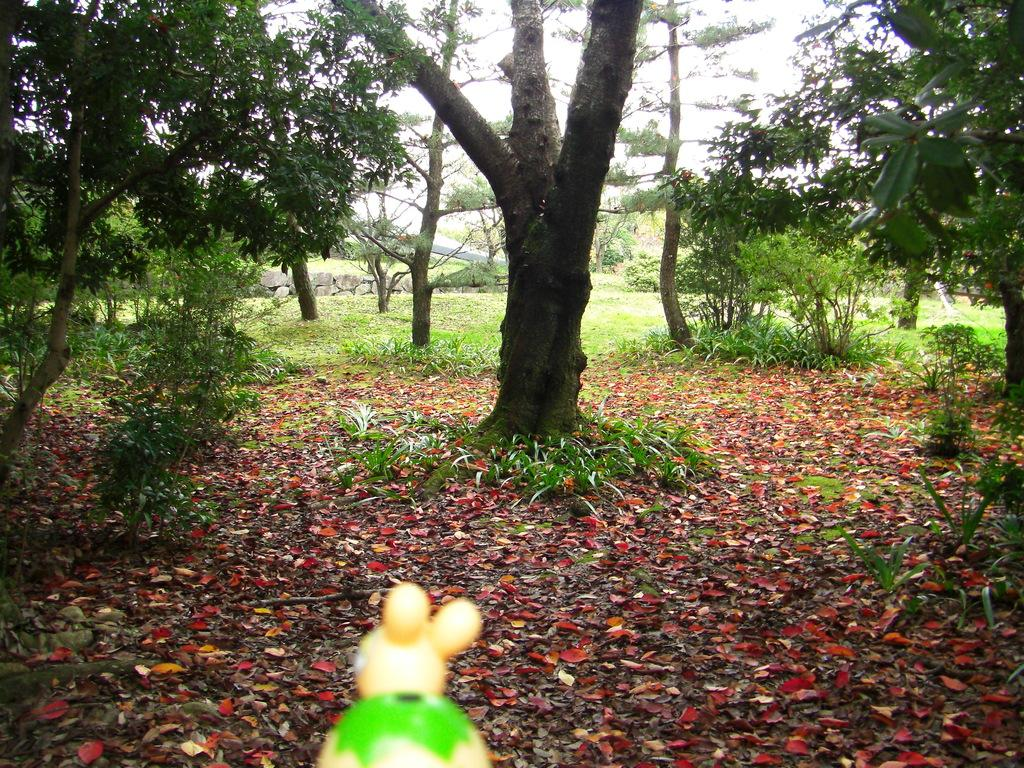What object is located at the bottom of the image? There is a toy at the bottom of the image. What can be seen in the background of the image? The sky, trees, plants, grass, leaves, and stones are visible in the background of the image. What is the average income of the women in the image? There are no women present in the image, so it is not possible to determine their average income. 